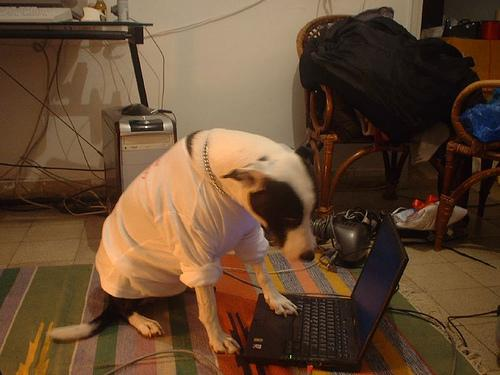What is the dog's paw resting on? computer 